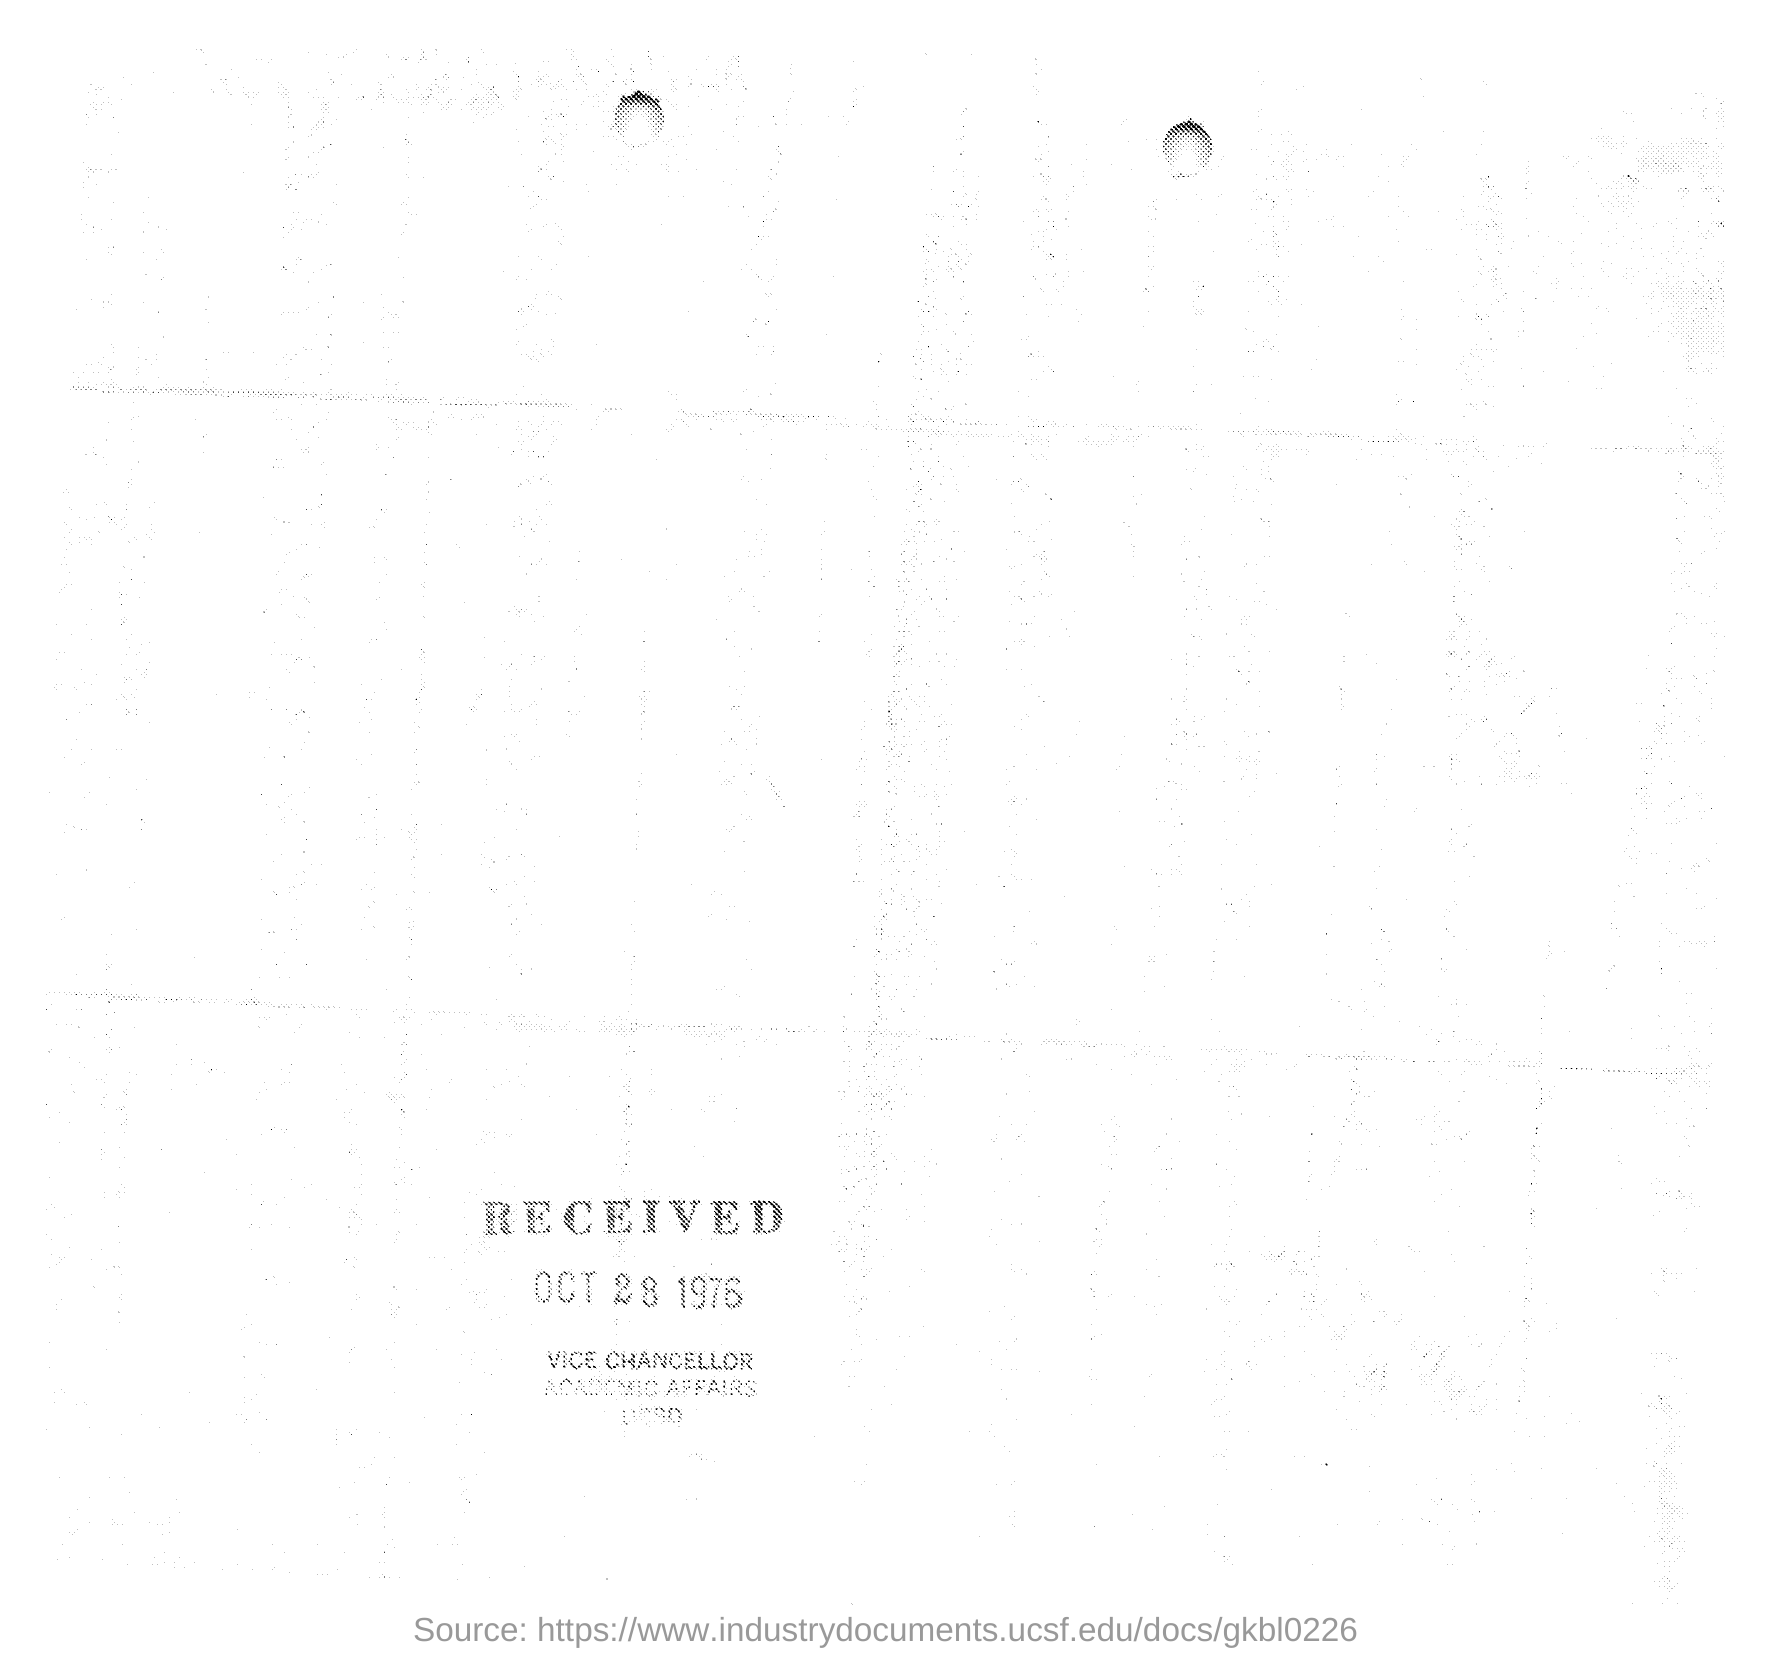Specify some key components in this picture. The document was received on October 28, 1976. 